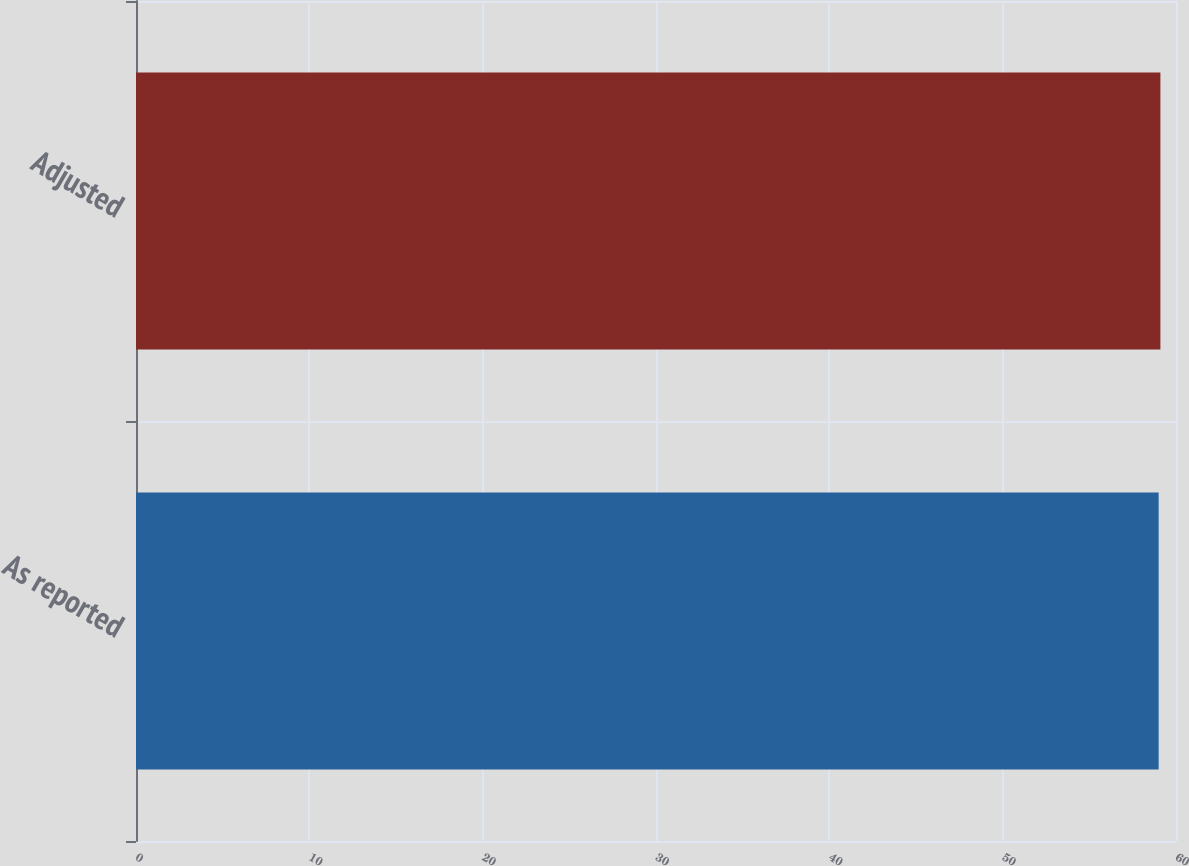Convert chart. <chart><loc_0><loc_0><loc_500><loc_500><bar_chart><fcel>As reported<fcel>Adjusted<nl><fcel>59<fcel>59.1<nl></chart> 